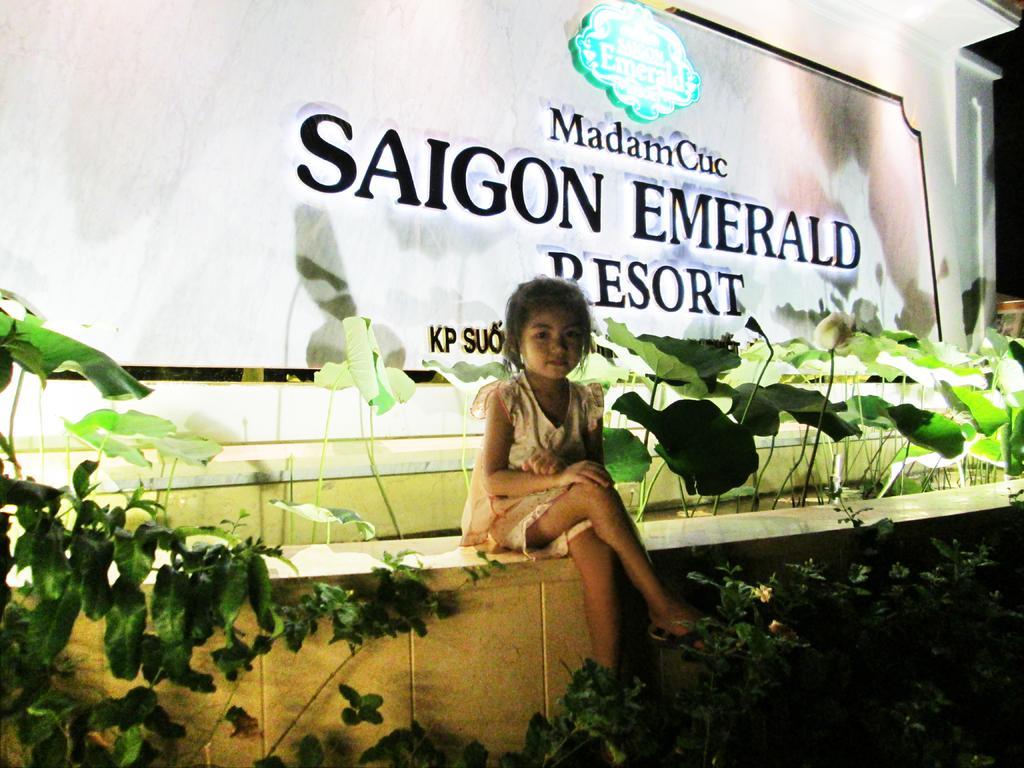How would you summarize this image in a sentence or two? In this picture we can see a girl sitting on the wall, plants, name board and some objects. 